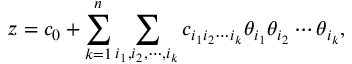Convert formula to latex. <formula><loc_0><loc_0><loc_500><loc_500>z = c _ { 0 } + \sum _ { k = 1 } ^ { n } \sum _ { i _ { 1 } , i _ { 2 } , \cdots , i _ { k } } c _ { i _ { 1 } i _ { 2 } \cdots i _ { k } } \theta _ { i _ { 1 } } \theta _ { i _ { 2 } } \cdots \theta _ { i _ { k } } ,</formula> 